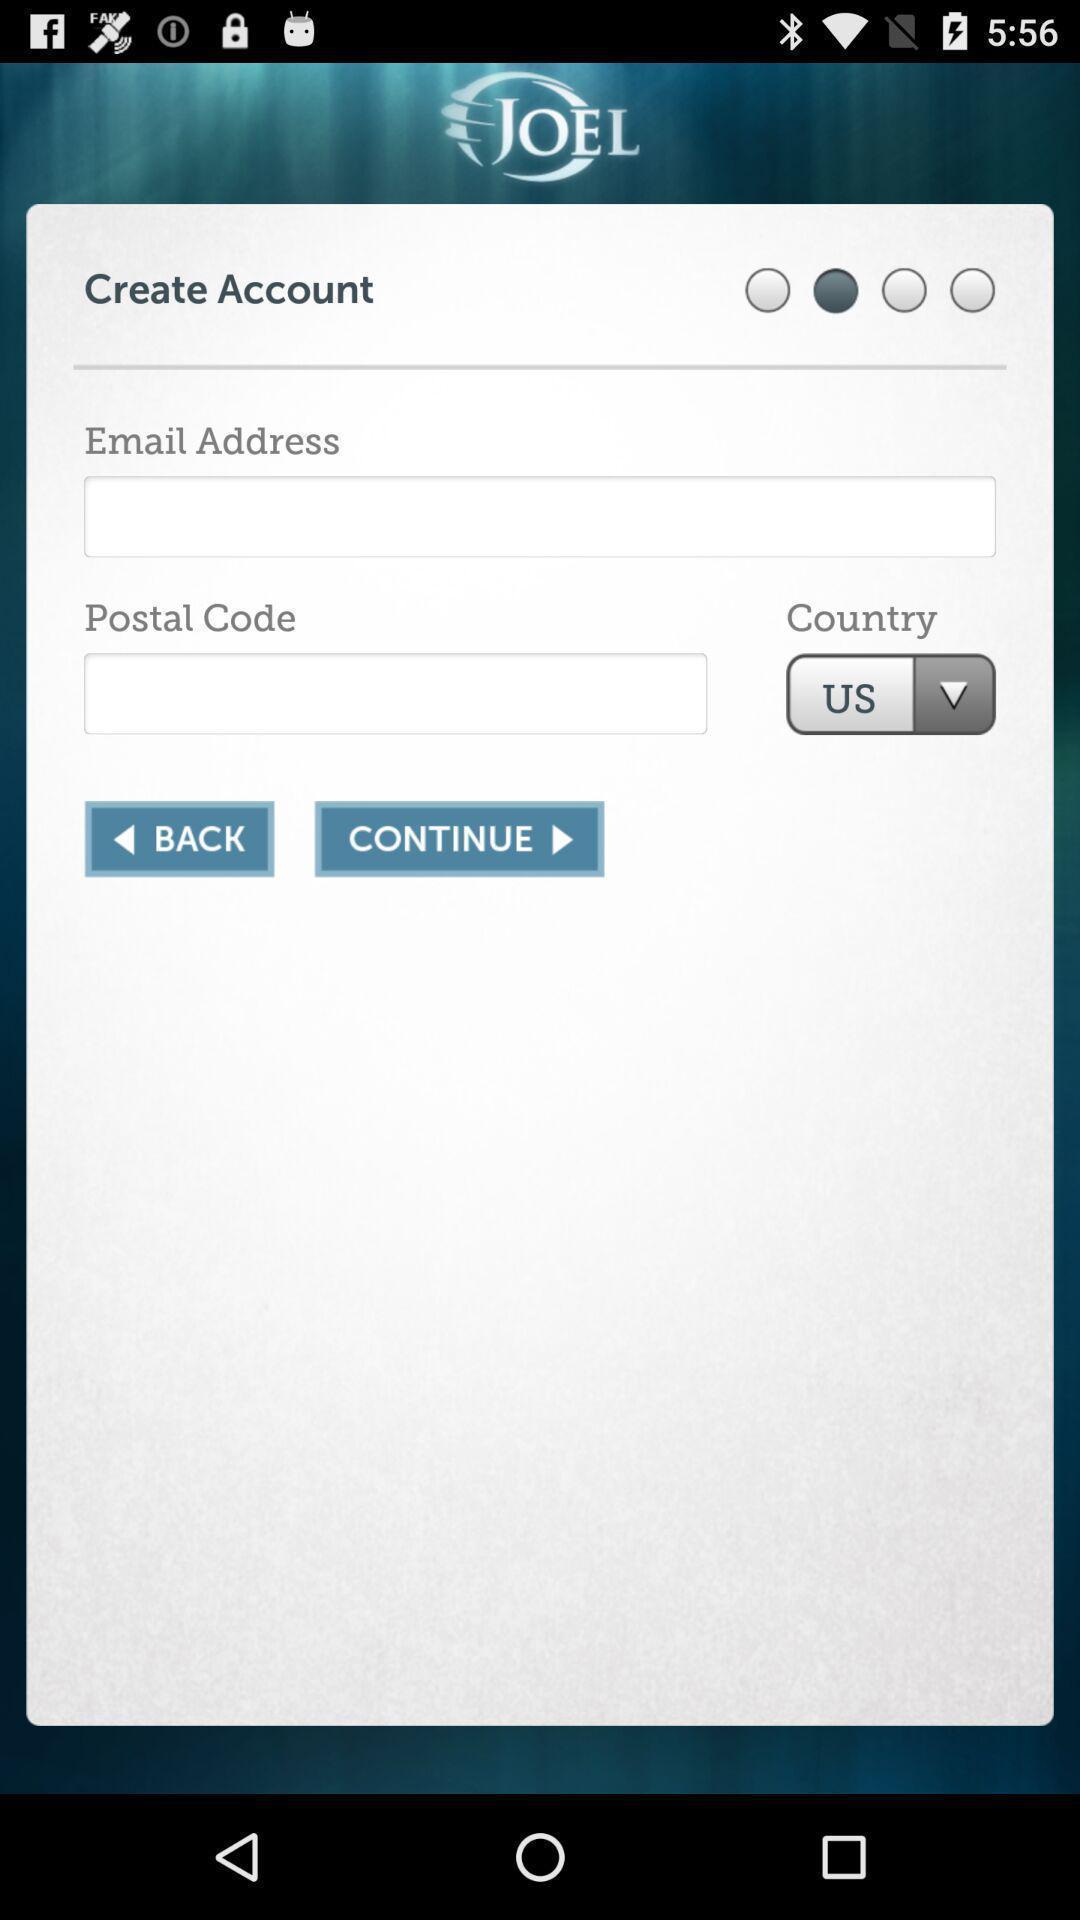Describe the visual elements of this screenshot. Screen showing page to create account. 